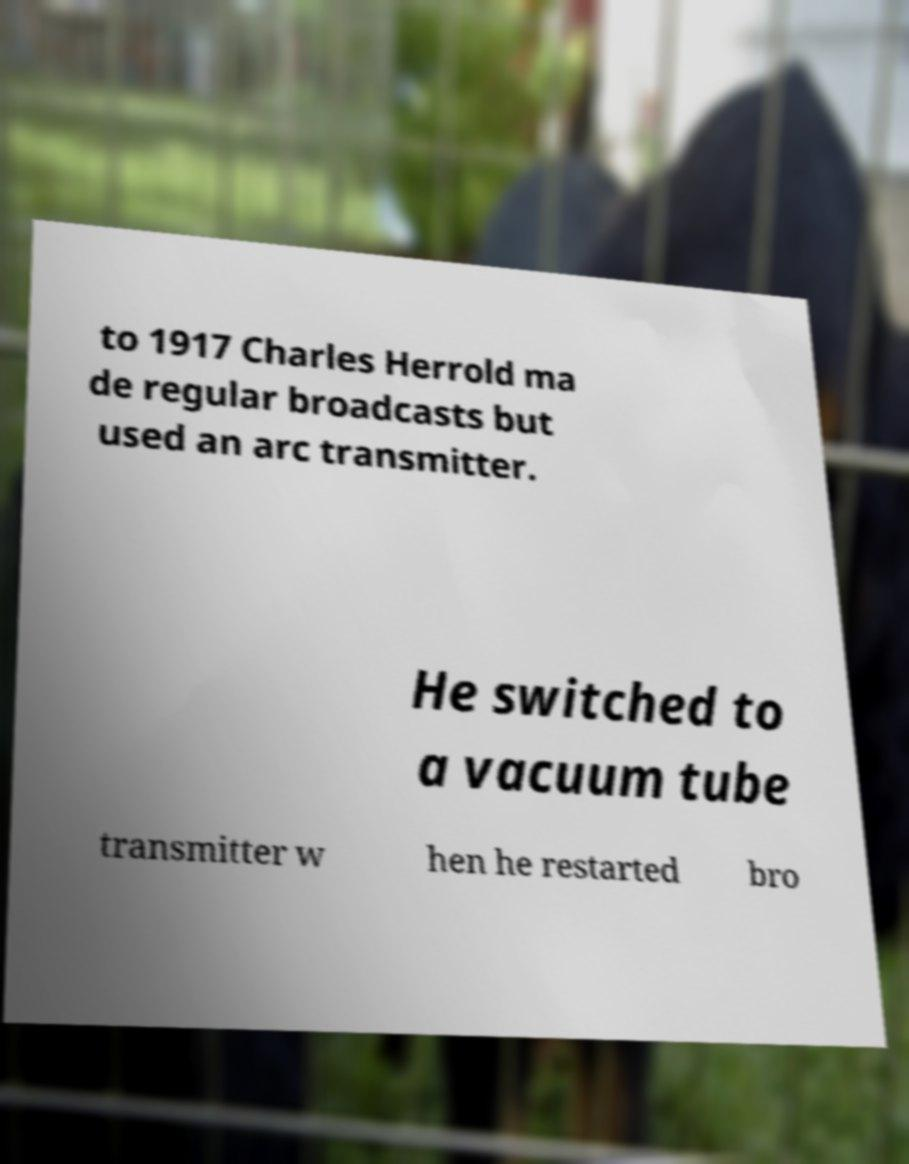Can you accurately transcribe the text from the provided image for me? to 1917 Charles Herrold ma de regular broadcasts but used an arc transmitter. He switched to a vacuum tube transmitter w hen he restarted bro 